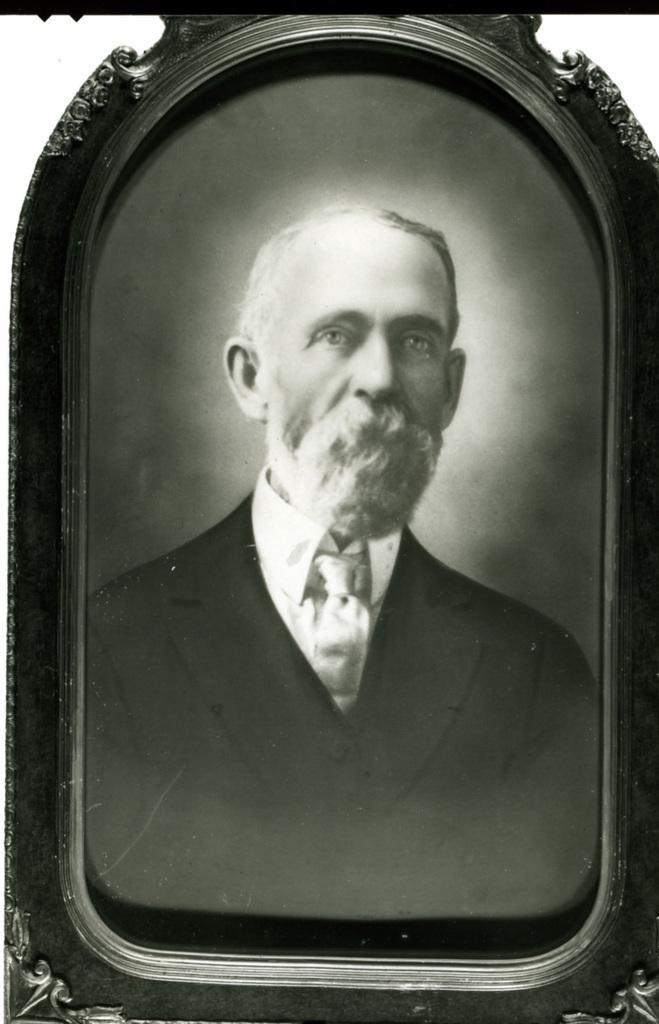In one or two sentences, can you explain what this image depicts? This picture is a black and white image. In this image we can see one black and white photo frame with one man photo. 